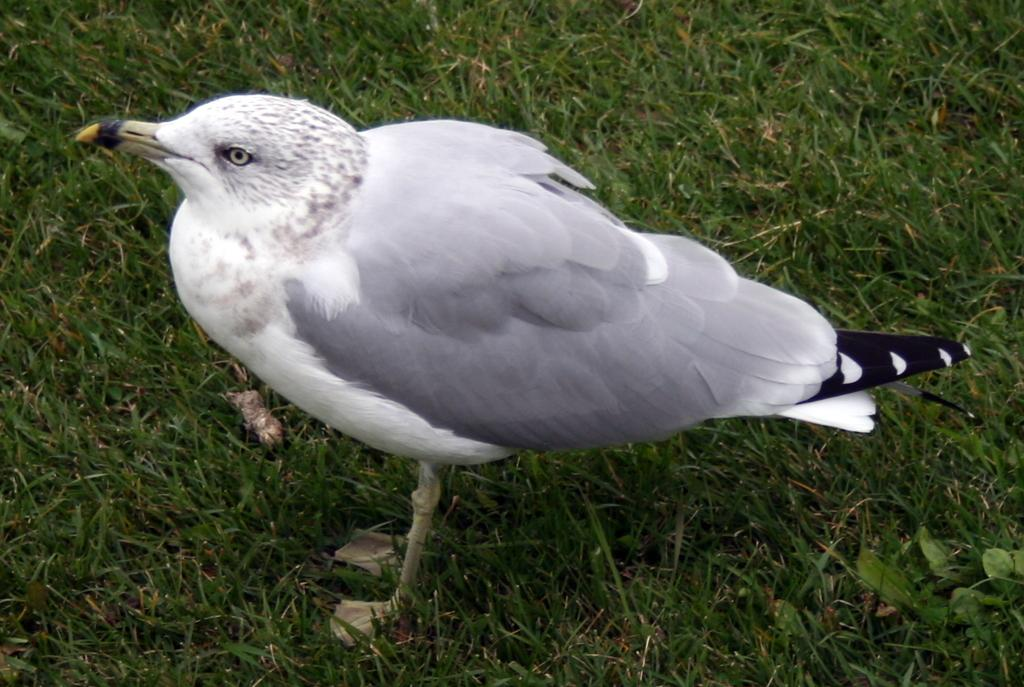What type of animal is present in the image? There is a bird in the image. What is the color of the bird in the image? The bird is white in color. What type of food is the bird eating in the image? There is no food visible in the image, and therefore no such activity can be observed. Where is the bird located in the image? The bird is located in the image, but the specific location is not mentioned in the provided facts. 